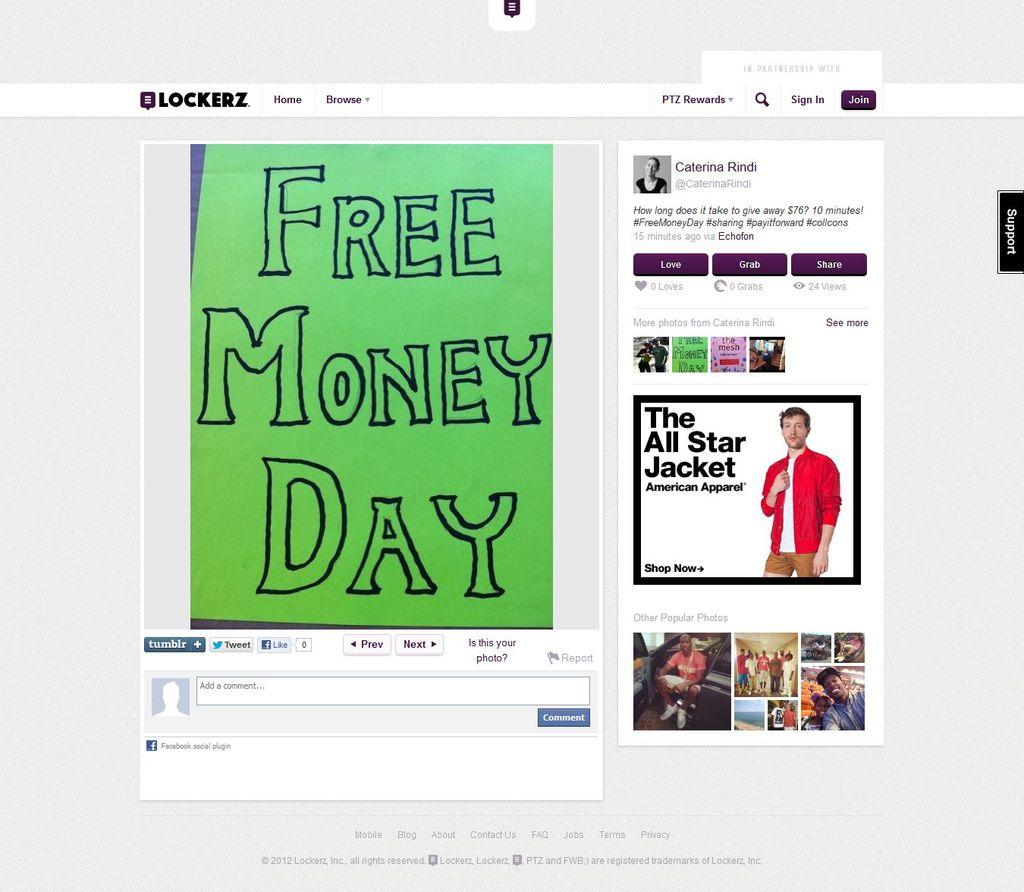Provide a one-sentence caption for the provided image. A website contains an article talking about an event called free money day. 